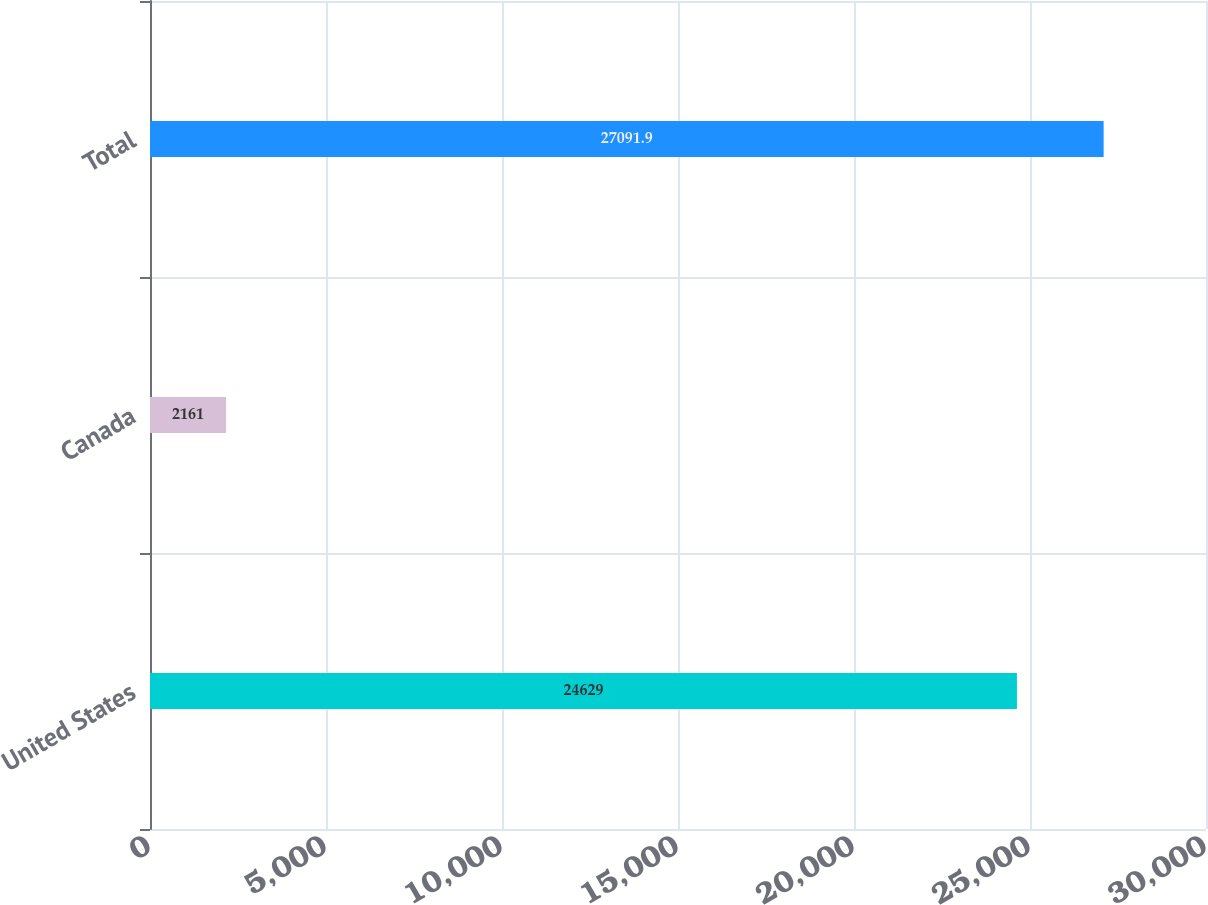Convert chart. <chart><loc_0><loc_0><loc_500><loc_500><bar_chart><fcel>United States<fcel>Canada<fcel>Total<nl><fcel>24629<fcel>2161<fcel>27091.9<nl></chart> 